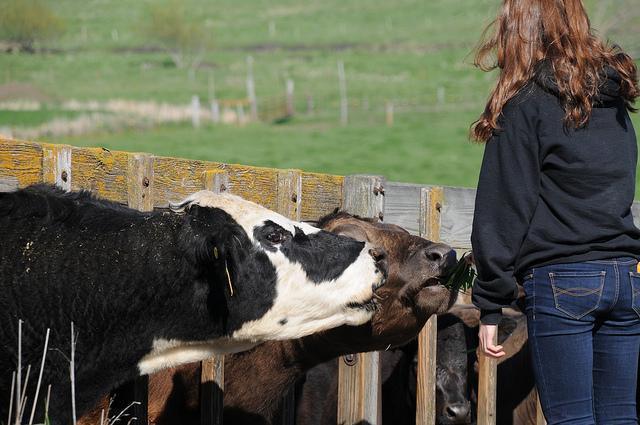Who is the woman feeding the cows?
Make your selection and explain in format: 'Answer: answer
Rationale: rationale.'
Options: Farm worker, animal rescuer, visitor, zookeeper. Answer: visitor.
Rationale: The woman is a visitor. 